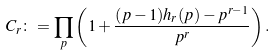<formula> <loc_0><loc_0><loc_500><loc_500>C _ { r } \colon = \prod _ { p } \left ( 1 + \frac { ( p - 1 ) h _ { r } ( p ) - p ^ { r - 1 } } { p ^ { r } } \right ) .</formula> 